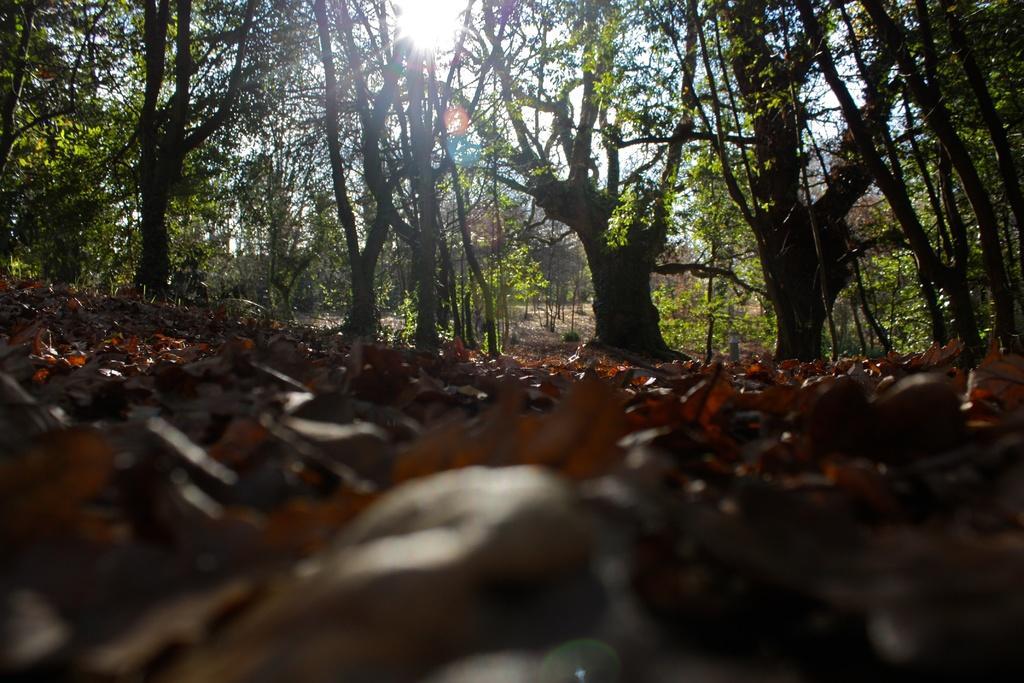In one or two sentences, can you explain what this image depicts? This is the picture of a forest. In this image there are trees. At the top there is sky and there is a sun. At the bottom there is ground and there are dried leaves. 